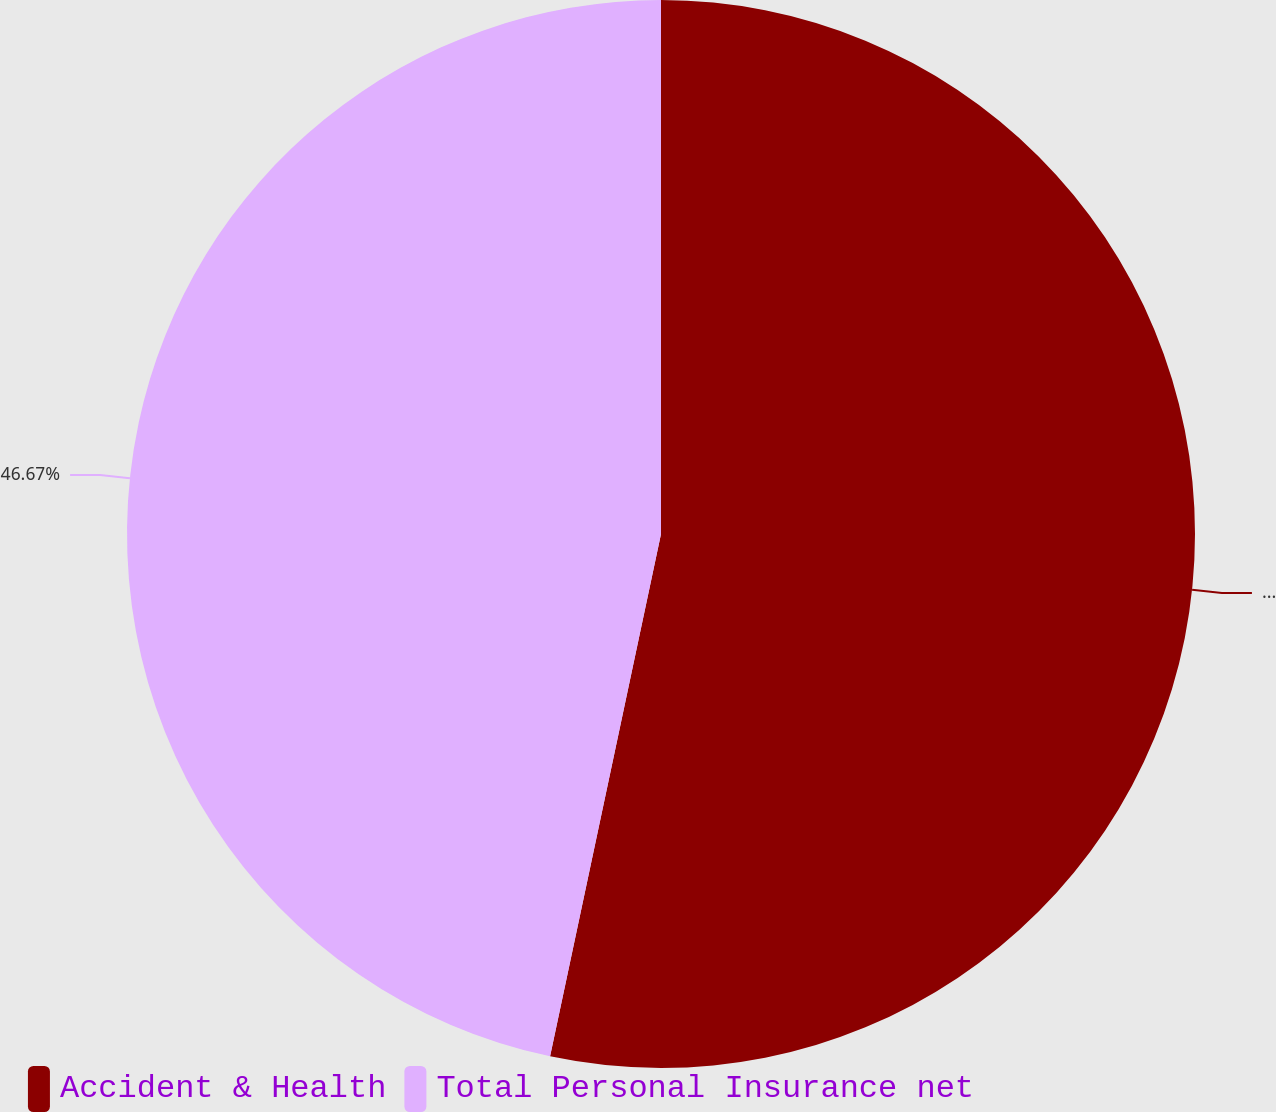<chart> <loc_0><loc_0><loc_500><loc_500><pie_chart><fcel>Accident & Health<fcel>Total Personal Insurance net<nl><fcel>53.33%<fcel>46.67%<nl></chart> 